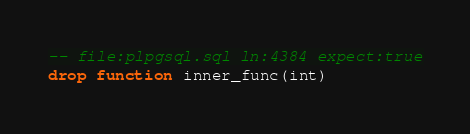<code> <loc_0><loc_0><loc_500><loc_500><_SQL_>-- file:plpgsql.sql ln:4384 expect:true
drop function inner_func(int)
</code> 